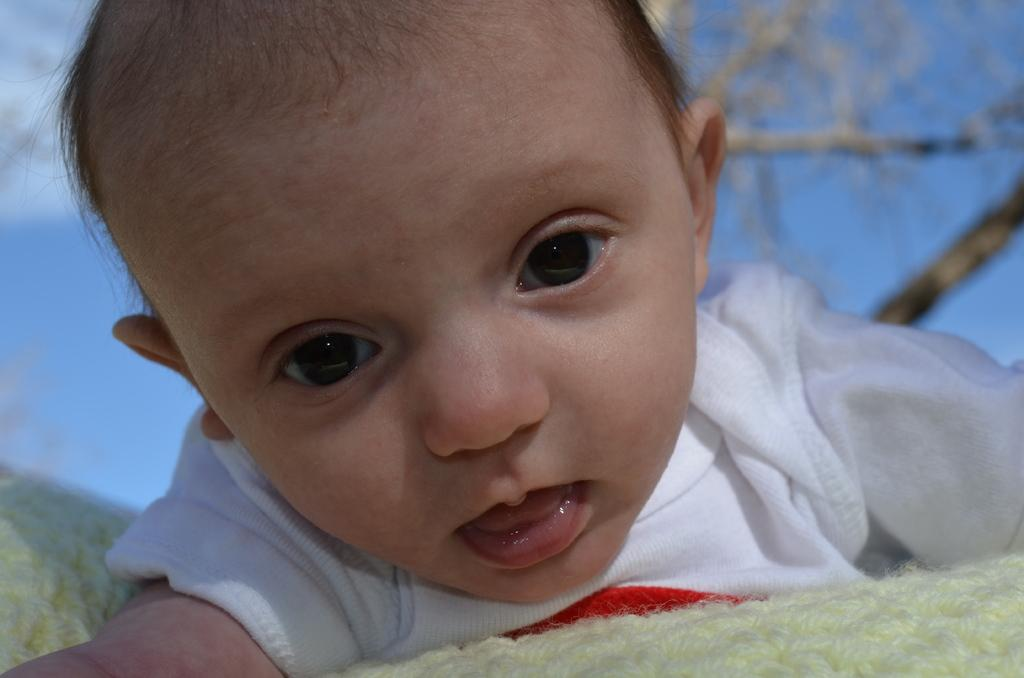What is the main subject in the foreground of the image? There is a baby in the foreground of the image. What can be seen at the bottom of the image? There is some cloth at the bottom of the image. What value is assigned to the letters in the image? There are no letters present in the image, so no value can be assigned. 